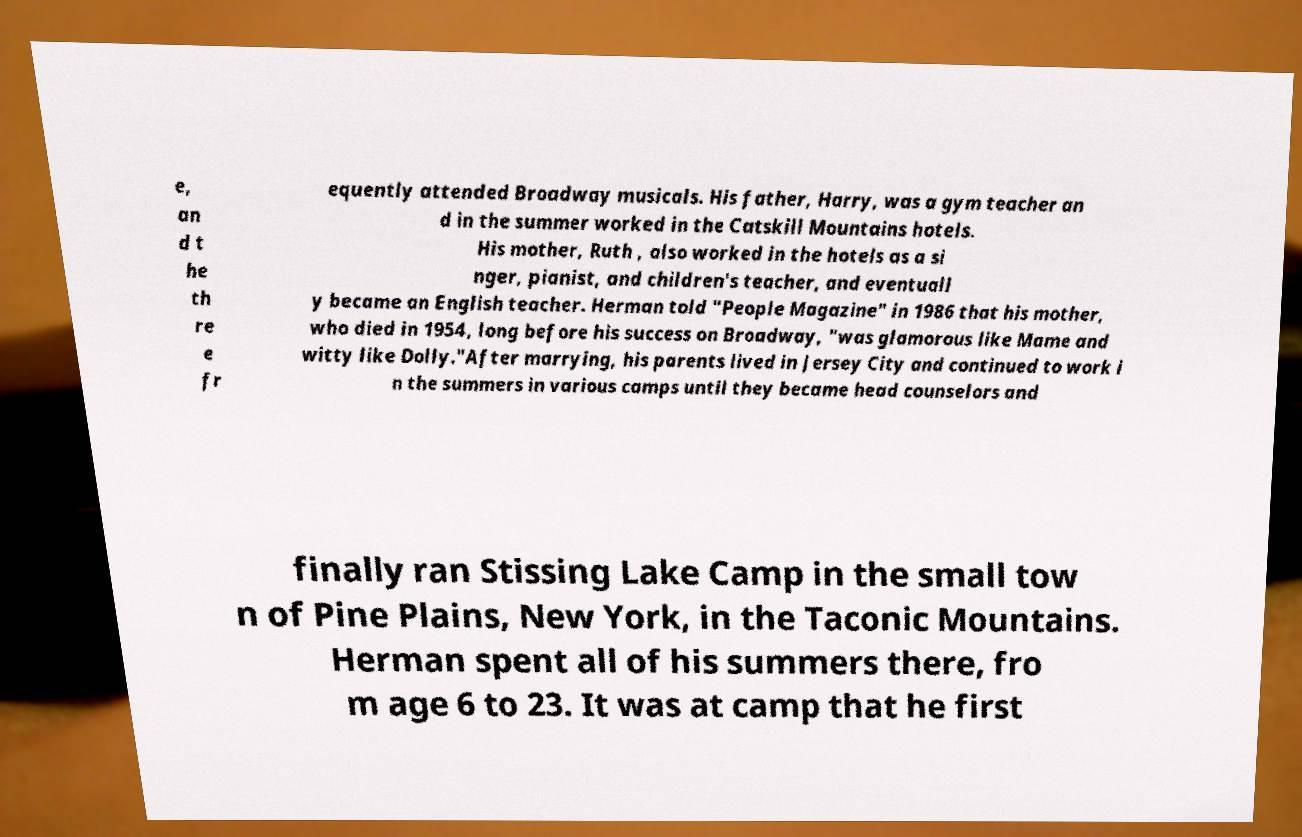Can you read and provide the text displayed in the image?This photo seems to have some interesting text. Can you extract and type it out for me? e, an d t he th re e fr equently attended Broadway musicals. His father, Harry, was a gym teacher an d in the summer worked in the Catskill Mountains hotels. His mother, Ruth , also worked in the hotels as a si nger, pianist, and children's teacher, and eventuall y became an English teacher. Herman told "People Magazine" in 1986 that his mother, who died in 1954, long before his success on Broadway, "was glamorous like Mame and witty like Dolly."After marrying, his parents lived in Jersey City and continued to work i n the summers in various camps until they became head counselors and finally ran Stissing Lake Camp in the small tow n of Pine Plains, New York, in the Taconic Mountains. Herman spent all of his summers there, fro m age 6 to 23. It was at camp that he first 